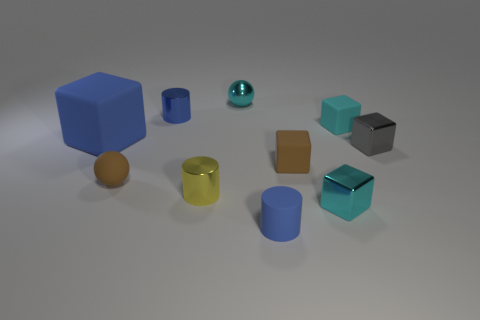What is the shape of the small metallic thing that is the same color as the metallic sphere?
Make the answer very short. Cube. There is a big blue object that is the same shape as the small cyan rubber thing; what is its material?
Keep it short and to the point. Rubber. Are there any other things that are the same material as the brown block?
Offer a very short reply. Yes. Do the tiny blue object in front of the cyan rubber cube and the cube left of the small yellow object have the same material?
Offer a very short reply. Yes. There is a shiny thing that is behind the tiny cylinder behind the tiny matte cube behind the tiny gray cube; what is its color?
Keep it short and to the point. Cyan. How many other objects are there of the same shape as the large object?
Ensure brevity in your answer.  4. Is the color of the tiny rubber sphere the same as the large object?
Offer a terse response. No. How many objects are either brown matte balls or tiny shiny cylinders that are in front of the gray metal object?
Your answer should be very brief. 2. Are there any brown matte spheres that have the same size as the gray metal object?
Your answer should be very brief. Yes. Do the cyan sphere and the gray cube have the same material?
Ensure brevity in your answer.  Yes. 